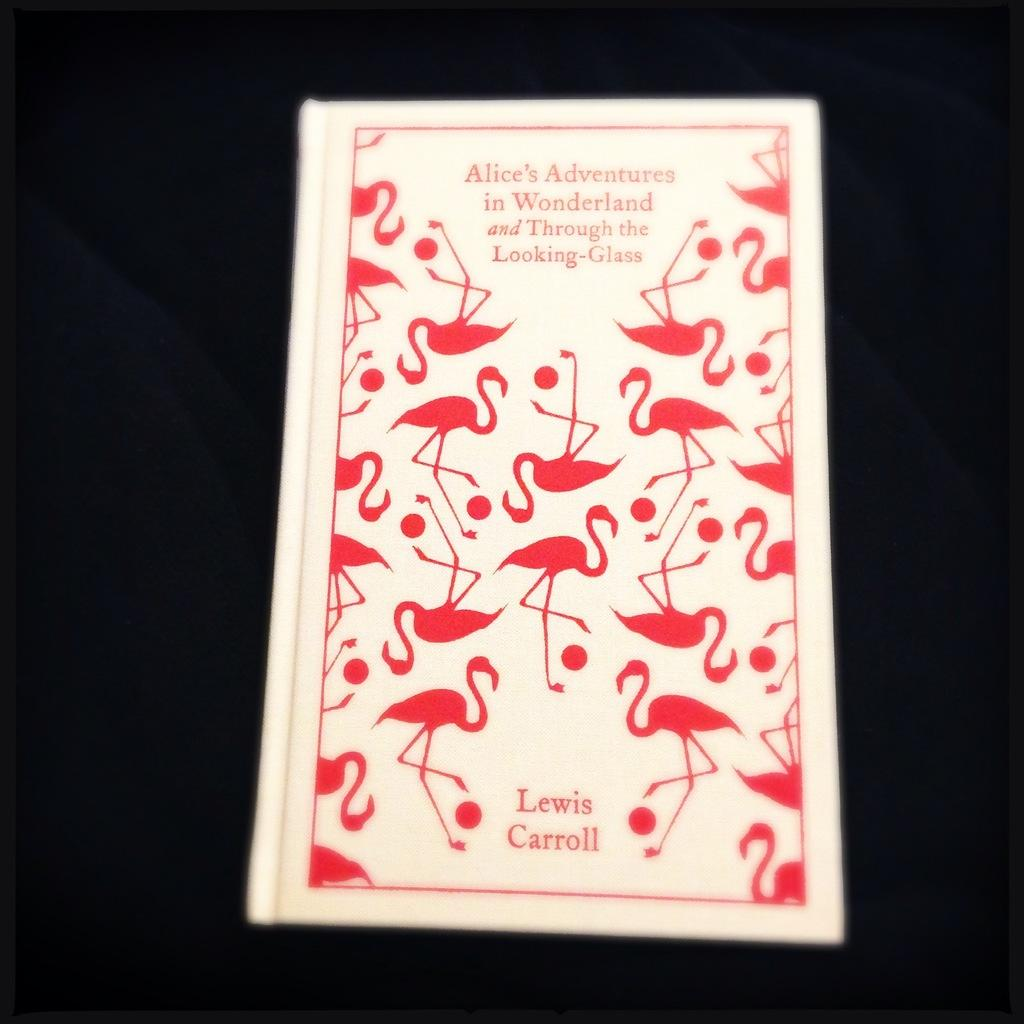<image>
Provide a brief description of the given image. The book Alice's Adventures in Wonderland and Through the Looking-Glass by Lewis Carroll. 